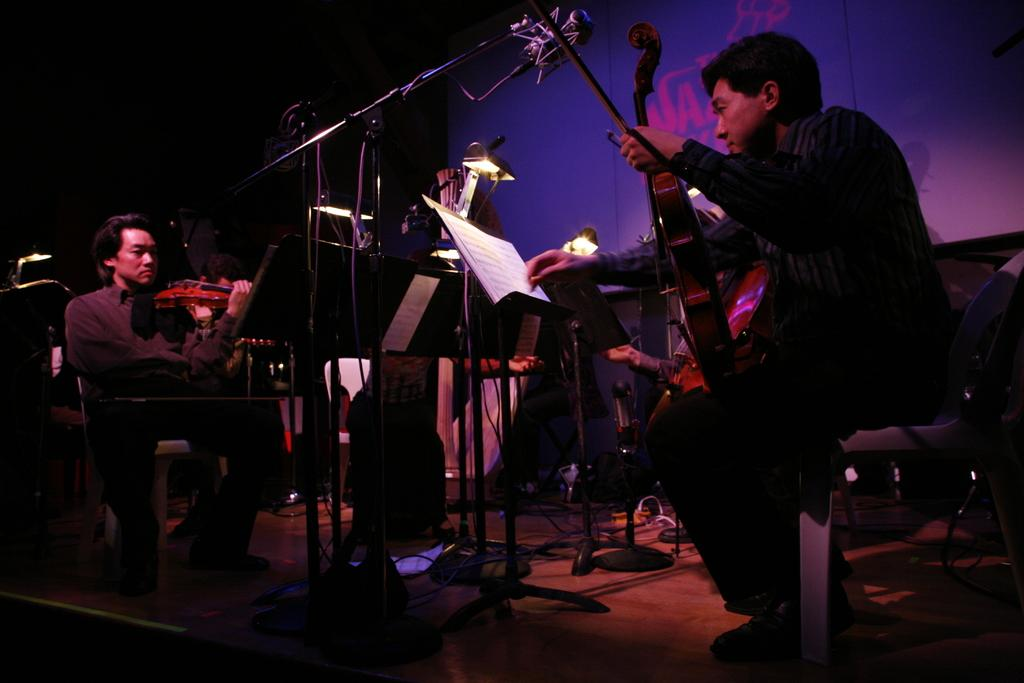What are the people in the image doing? The people in the image are playing violins. What object can be seen on a stand in the image? There is a book placed on a stand in the image. What devices are present to amplify sound in the image? There are microphones in the image. What can be seen in the background of the image? There is a light and a screen in the background of the image. What type of lunch is being served in the image? There is no lunch present in the image; it features people playing violins, a book on a stand, microphones, and a light and screen in the background. 